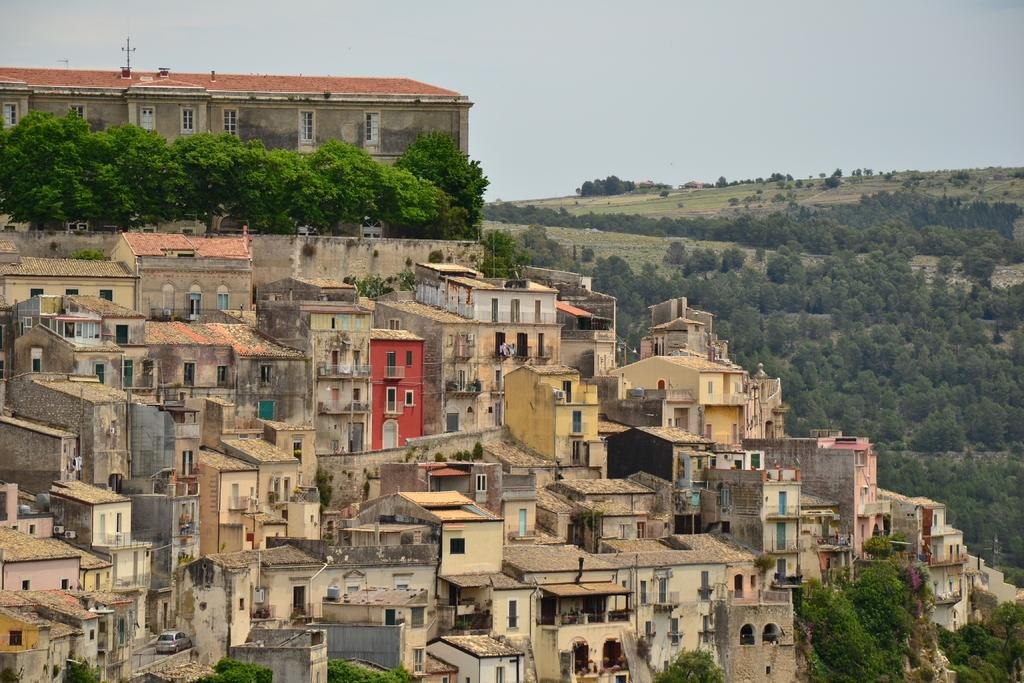What is visible at the top of the image? The sky is visible at the top of the image. What type of structures can be seen in the image? There are buildings in the image. What type of vegetation is on the right side of the image? There are grass and trees on the right side of the image. How does the grass compare to the brake in the image? There is no brake present in the image, so it cannot be compared to the grass. What type of border is visible in the image? There is no mention of a border in the provided facts, so it cannot be identified in the image. 